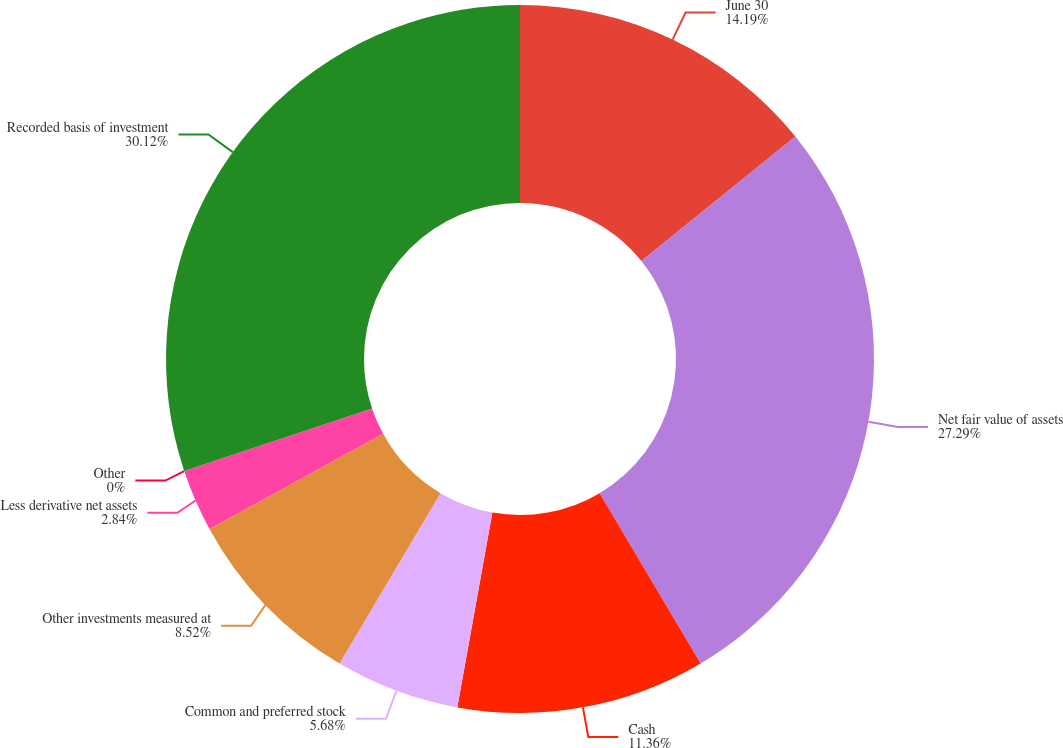Convert chart to OTSL. <chart><loc_0><loc_0><loc_500><loc_500><pie_chart><fcel>June 30<fcel>Net fair value of assets<fcel>Cash<fcel>Common and preferred stock<fcel>Other investments measured at<fcel>Less derivative net assets<fcel>Other<fcel>Recorded basis of investment<nl><fcel>14.19%<fcel>27.29%<fcel>11.36%<fcel>5.68%<fcel>8.52%<fcel>2.84%<fcel>0.0%<fcel>30.13%<nl></chart> 